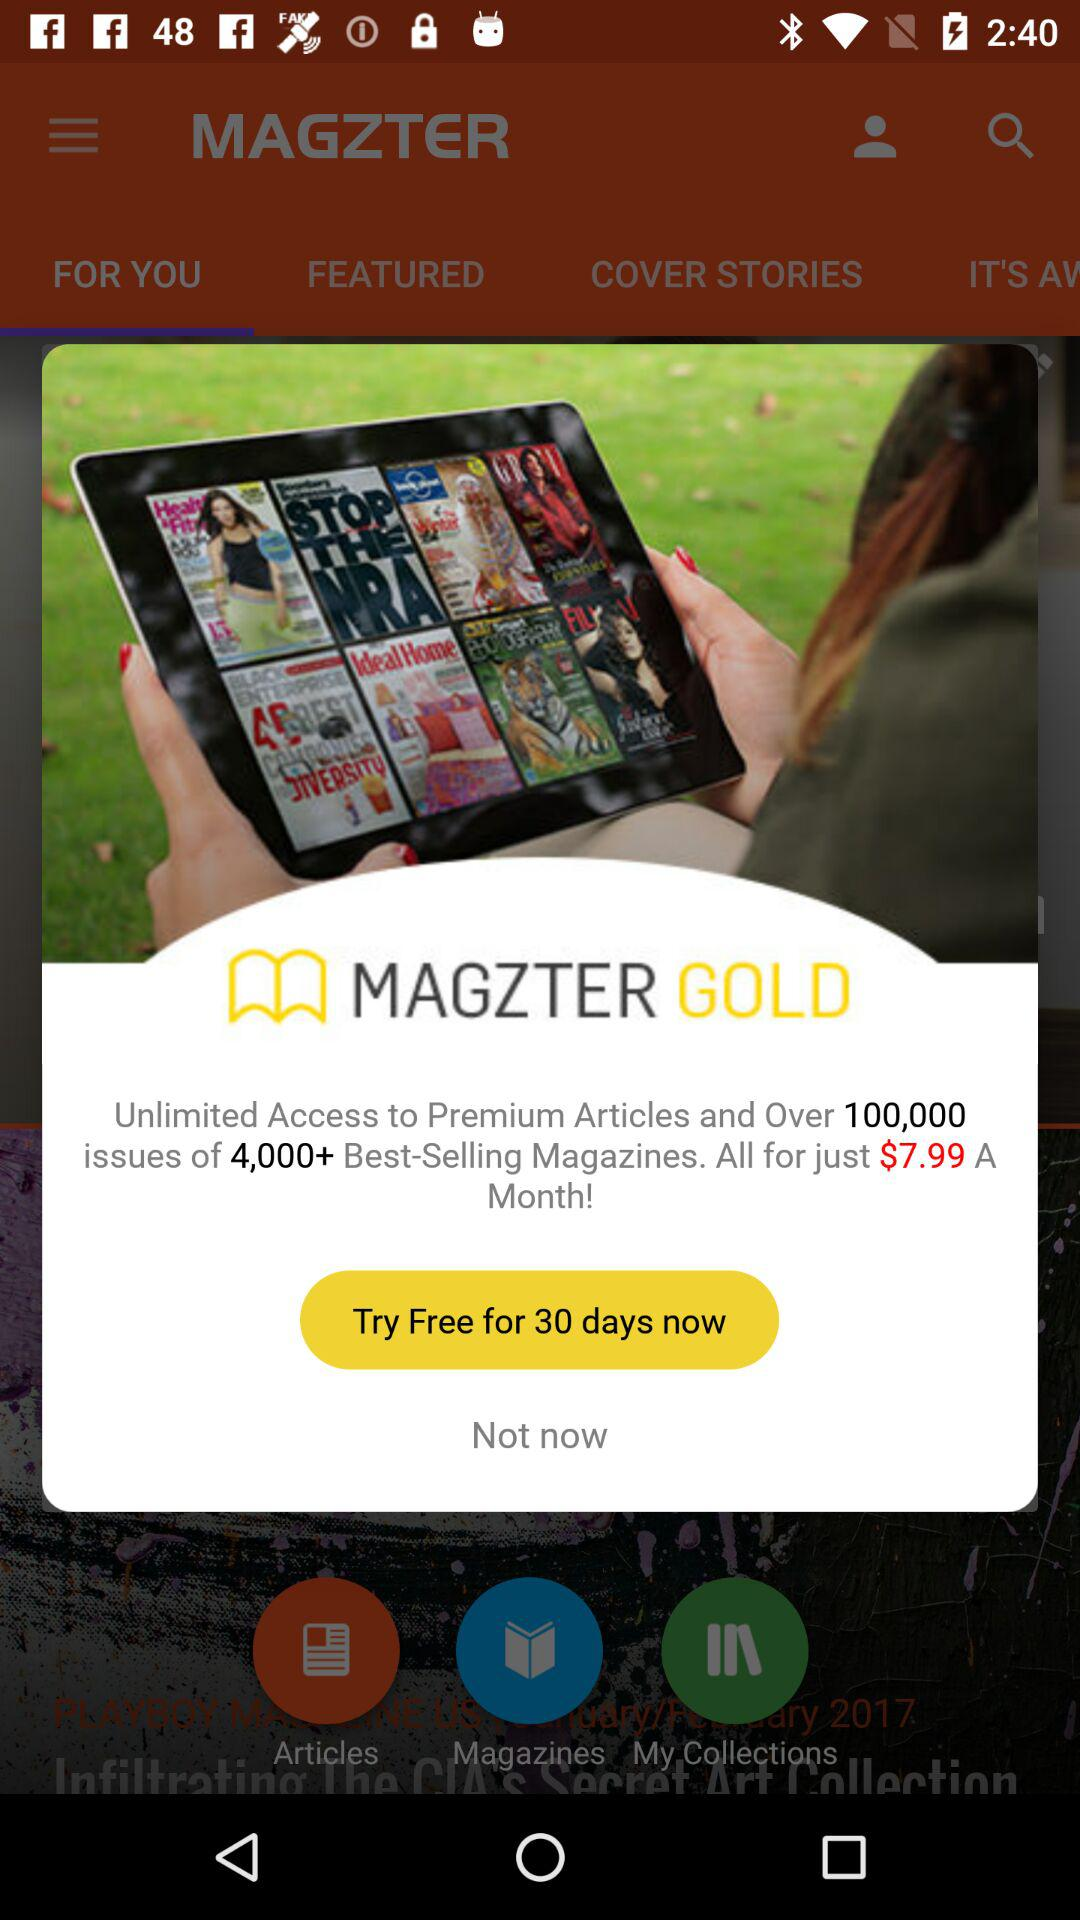What is the name of the application? The application name is "MAGZTER". 